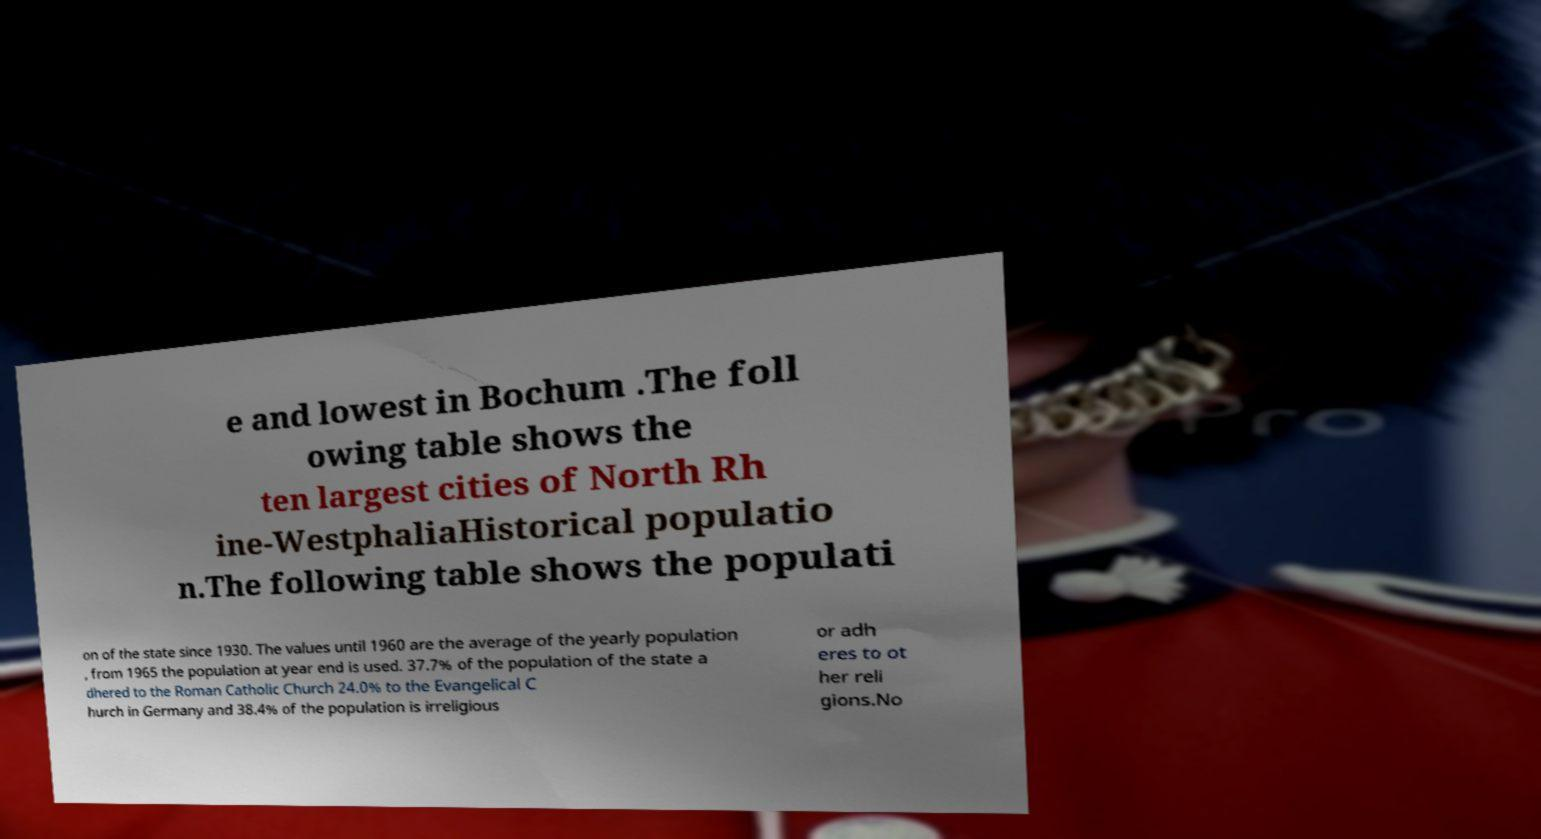There's text embedded in this image that I need extracted. Can you transcribe it verbatim? e and lowest in Bochum .The foll owing table shows the ten largest cities of North Rh ine-WestphaliaHistorical populatio n.The following table shows the populati on of the state since 1930. The values until 1960 are the average of the yearly population , from 1965 the population at year end is used. 37.7% of the population of the state a dhered to the Roman Catholic Church 24.0% to the Evangelical C hurch in Germany and 38.4% of the population is irreligious or adh eres to ot her reli gions.No 